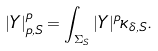<formula> <loc_0><loc_0><loc_500><loc_500>| Y | ^ { p } _ { p , S } = \int _ { \Sigma _ { S } } | Y | ^ { p } \kappa _ { \delta , S } .</formula> 